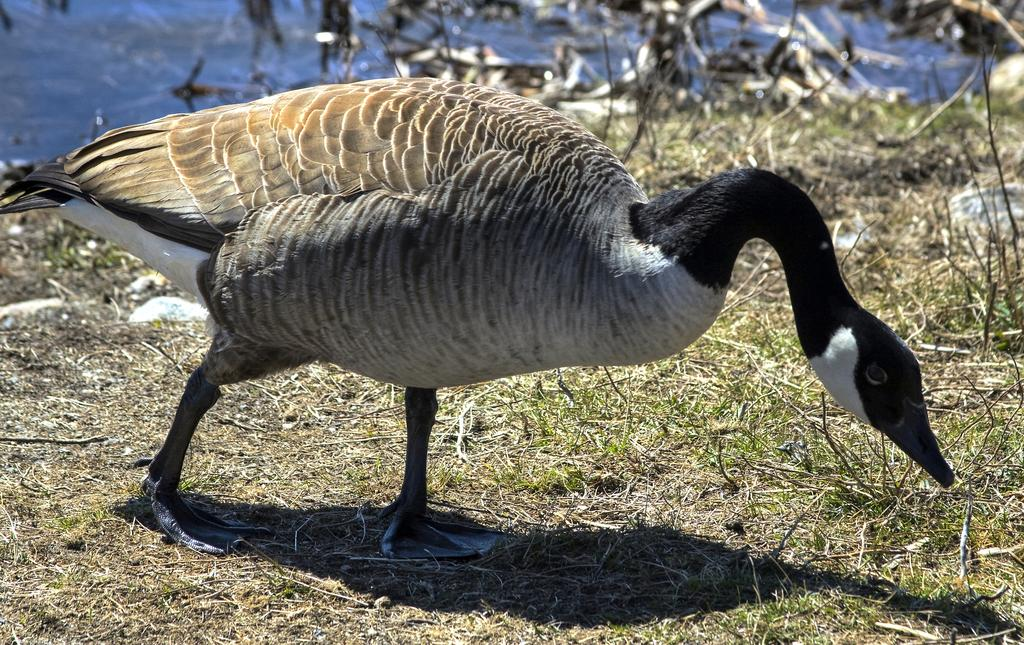Where was the picture taken? The picture was clicked outside. What is the main subject in the center of the image? There is a bird in the center of the image, which appears to be a goose. What type of vegetation can be seen in the image? There is grass visible in the image. What can be seen in the background of the image? There is a water body and other objects visible in the background of the image. What type of pear is being used as a nail in the image? There is no pear or nail present in the image. What is the goose doing with the need in the image? There is no need present in the image, and the goose is not performing any action with a need. 